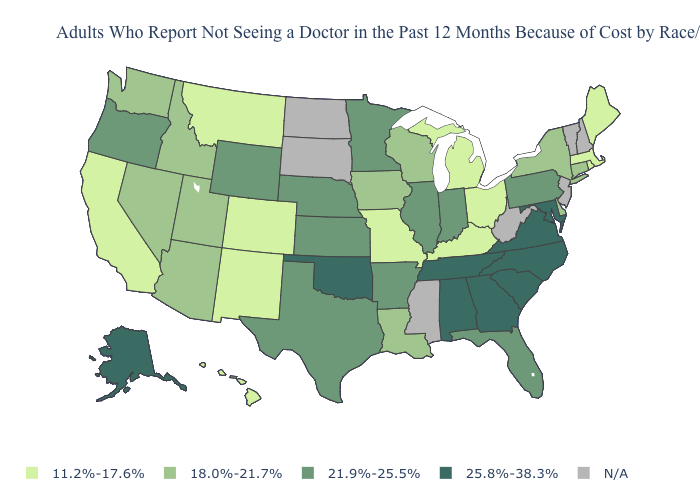Which states hav the highest value in the Northeast?
Quick response, please. Pennsylvania. Is the legend a continuous bar?
Short answer required. No. What is the value of Wyoming?
Be succinct. 21.9%-25.5%. What is the value of Oklahoma?
Quick response, please. 25.8%-38.3%. Which states have the highest value in the USA?
Answer briefly. Alabama, Alaska, Georgia, Maryland, North Carolina, Oklahoma, South Carolina, Tennessee, Virginia. Among the states that border New Mexico , does Colorado have the lowest value?
Keep it brief. Yes. What is the value of Oklahoma?
Short answer required. 25.8%-38.3%. What is the lowest value in the USA?
Give a very brief answer. 11.2%-17.6%. Does the map have missing data?
Give a very brief answer. Yes. Name the states that have a value in the range 25.8%-38.3%?
Concise answer only. Alabama, Alaska, Georgia, Maryland, North Carolina, Oklahoma, South Carolina, Tennessee, Virginia. Does the first symbol in the legend represent the smallest category?
Be succinct. Yes. What is the value of Montana?
Give a very brief answer. 11.2%-17.6%. What is the value of West Virginia?
Keep it brief. N/A. What is the value of Tennessee?
Be succinct. 25.8%-38.3%. What is the value of Oklahoma?
Keep it brief. 25.8%-38.3%. 